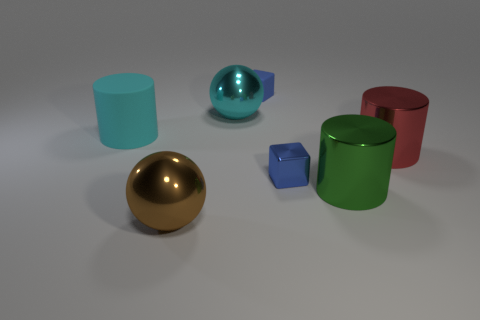There is a blue cube that is the same material as the brown thing; what is its size?
Offer a very short reply. Small. How many big objects are either cyan cylinders or green objects?
Provide a short and direct response. 2. There is a metal object on the left side of the large sphere to the right of the big shiny object that is in front of the big green object; what size is it?
Your answer should be compact. Large. What number of brown shiny objects have the same size as the green metallic cylinder?
Provide a succinct answer. 1. How many objects are either small metallic spheres or shiny spheres that are on the right side of the brown object?
Ensure brevity in your answer.  1. What shape is the large green metallic object?
Your response must be concise. Cylinder. Is the color of the big matte thing the same as the metallic cube?
Your answer should be compact. No. There is a thing that is the same size as the shiny block; what is its color?
Offer a terse response. Blue. How many green objects are either small metallic objects or big objects?
Provide a short and direct response. 1. Is the number of red metal cylinders greater than the number of big purple metal cubes?
Give a very brief answer. Yes. 